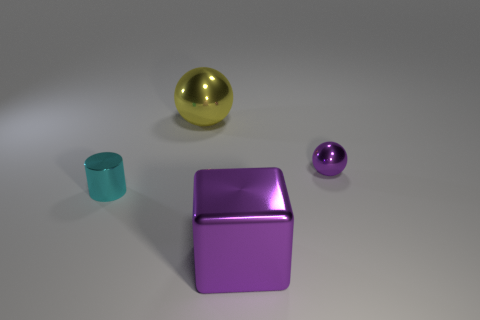There is a metal object that is the same color as the cube; what shape is it?
Keep it short and to the point. Sphere. How many purple balls are left of the small purple shiny object?
Your response must be concise. 0. There is a purple metallic thing in front of the cyan shiny thing to the left of the metal sphere that is left of the large purple cube; what is its size?
Provide a succinct answer. Large. Do the yellow thing and the small metallic thing that is to the right of the yellow metallic ball have the same shape?
Make the answer very short. Yes. The cube that is the same material as the yellow ball is what size?
Your response must be concise. Large. Is there anything else of the same color as the big sphere?
Your answer should be compact. No. What is the purple thing that is on the left side of the metal thing on the right side of the large cube that is in front of the tiny cyan cylinder made of?
Your response must be concise. Metal. How many metal objects are large purple cubes or cyan cylinders?
Keep it short and to the point. 2. Do the tiny sphere and the metal cube have the same color?
Offer a very short reply. Yes. How many objects are either large shiny balls or metal things that are on the right side of the cyan shiny thing?
Offer a terse response. 3. 